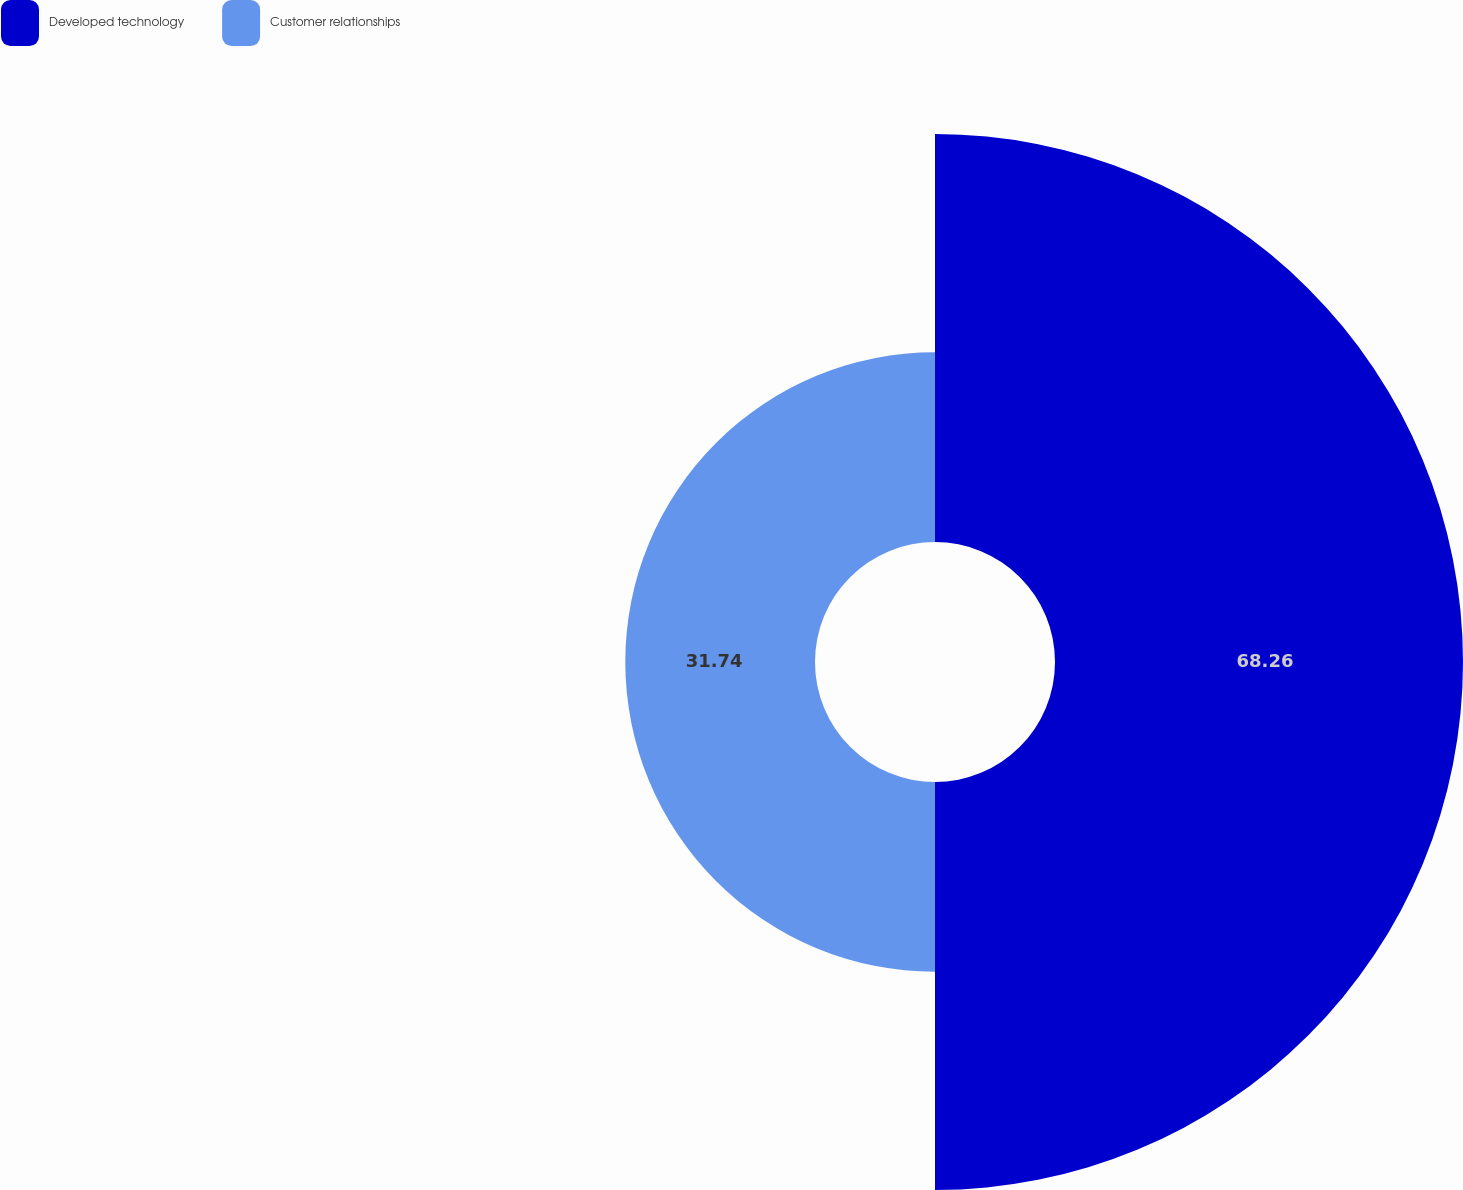Convert chart to OTSL. <chart><loc_0><loc_0><loc_500><loc_500><pie_chart><fcel>Developed technology<fcel>Customer relationships<nl><fcel>68.26%<fcel>31.74%<nl></chart> 